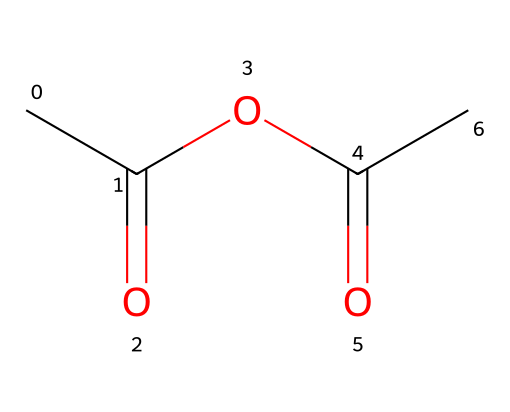What is the chemical name of the compound represented by the SMILES? The SMILES representation CC(=O)OC(=O)C corresponds to acetic anhydride, which is derived from acetic acid through the removal of a water molecule.
Answer: acetic anhydride How many carbon atoms are present in this chemical structure? The SMILES indicates there are four carbon atoms; they are represented as "C" in the formula, counted directly from the structure.
Answer: four What type of bonds are present in this molecule? The structure reveals both single and double bonds: single bonds connect the carbon atoms to oxygen in the anhydride functional group and the methyl group, while double bonds are found in the carbonyl groups (=O).
Answer: both single and double bonds Which functional groups are present in acetic anhydride? Analyzing the structure, the molecule contains carbonyl (C=O) and ester (C-O-C structure) functional groups, characteristic of anhydrides.
Answer: carbonyl and ester How does the presence of acyloxy influence its reactivity? The presence of the acyloxy group (O=C-O) increases the reactivity as it can easily undergo hydrolysis or react with alcohols to form esters, due to its high electrophilicity.
Answer: increases reactivity Is acetic anhydride used for wood staining? Yes, acetic anhydride is utilized in some wood staining processes due to its ability to modify cellulosic materials, enhancing color penetration and bonding.
Answer: yes 